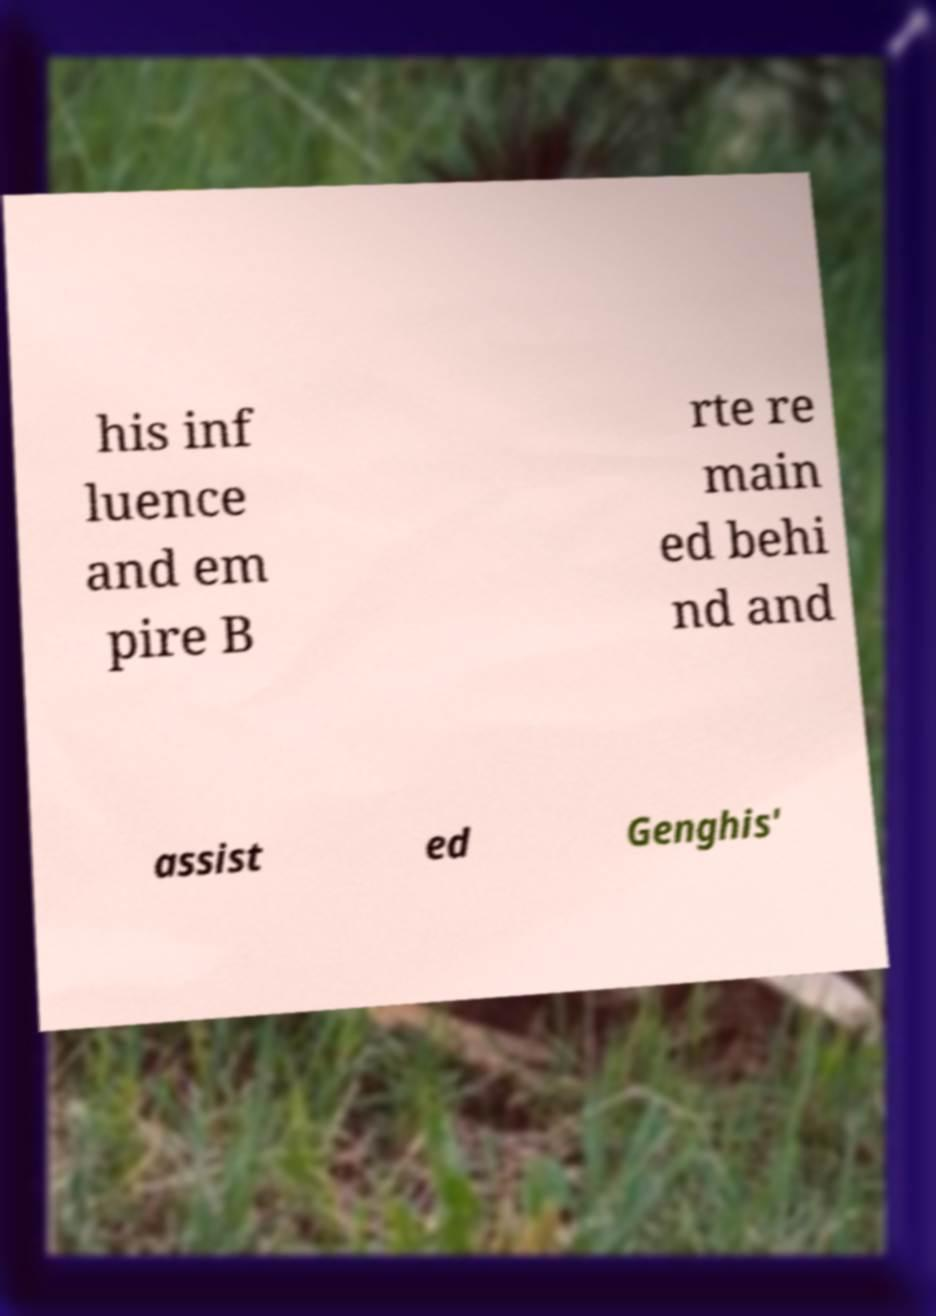Could you assist in decoding the text presented in this image and type it out clearly? his inf luence and em pire B rte re main ed behi nd and assist ed Genghis' 